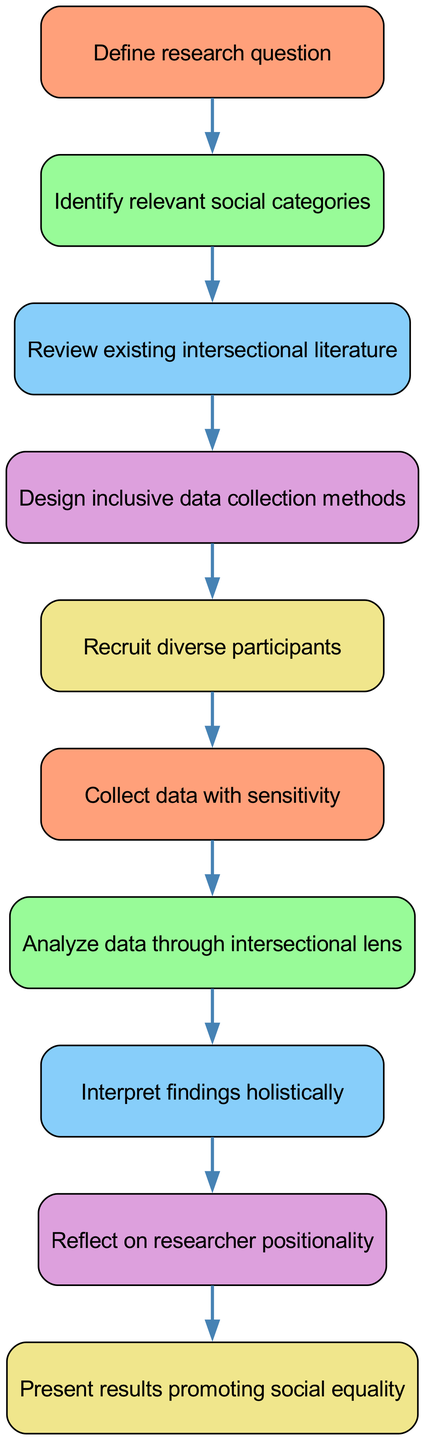What is the first step in the diagram? The first step in the diagram is to "Define research question," which is the first element listed at the top of the flow chart.
Answer: Define research question How many total steps are represented in the diagram? By counting all the distinct nodes in the diagram, we find there are ten steps shown in the flow.
Answer: Ten What step comes after "Recruit diverse participants"? The step that follows "Recruit diverse participants" is "Collect data with sensitivity," which is the subsequent node in the flow.
Answer: Collect data with sensitivity Which node addresses the interpretation of research findings? The node that focuses on interpreting findings is "Interpret findings holistically," which is a key step in understanding the data.
Answer: Interpret findings holistically What is the ultimate aim of the last step in the diagram? The last step outlines the goal to "Present results promoting social equality," indicating it’s designed to advocate for social equality through the research findings.
Answer: Present results promoting social equality How does "Review existing intersectional literature" relate to the overall research process? "Review existing intersectional literature" aids in building upon established knowledge and contextualizing the new research, making it crucial for a well-rounded approach.
Answer: It provides context What is the significance of analyzing data through an intersectional lens? Analyzing data through an intersectional lens allows researchers to understand how overlapping social identities affect experiences and outcomes, enabling a more nuanced analysis.
Answer: It enhances understanding 